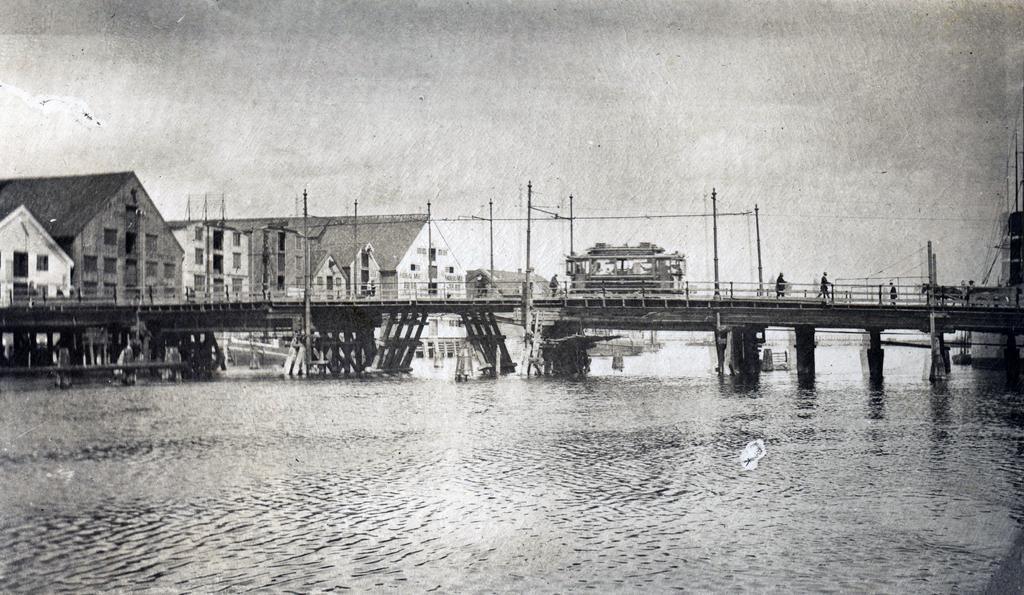Can you describe this image briefly? In this black and white image there is a bridge on the water. There are a few people walking on the bridge. In the background there are houses and poles. At the bottom there is the water. At the top there is the sky. 